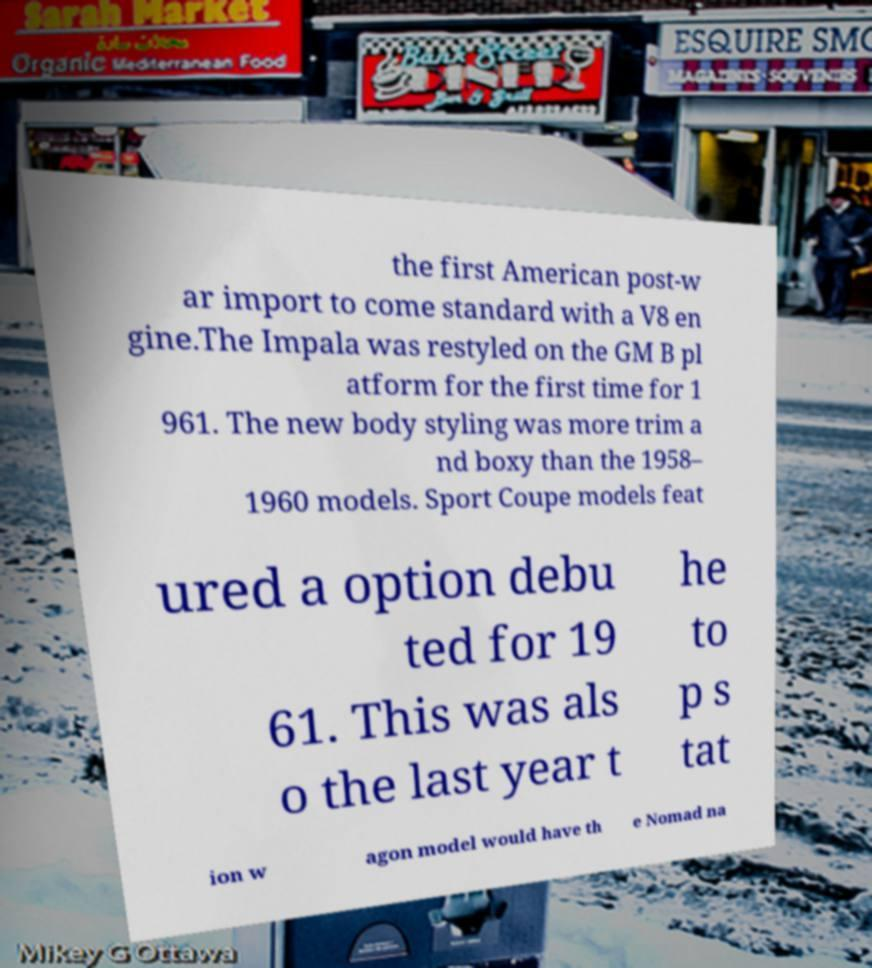Can you accurately transcribe the text from the provided image for me? the first American post-w ar import to come standard with a V8 en gine.The Impala was restyled on the GM B pl atform for the first time for 1 961. The new body styling was more trim a nd boxy than the 1958– 1960 models. Sport Coupe models feat ured a option debu ted for 19 61. This was als o the last year t he to p s tat ion w agon model would have th e Nomad na 